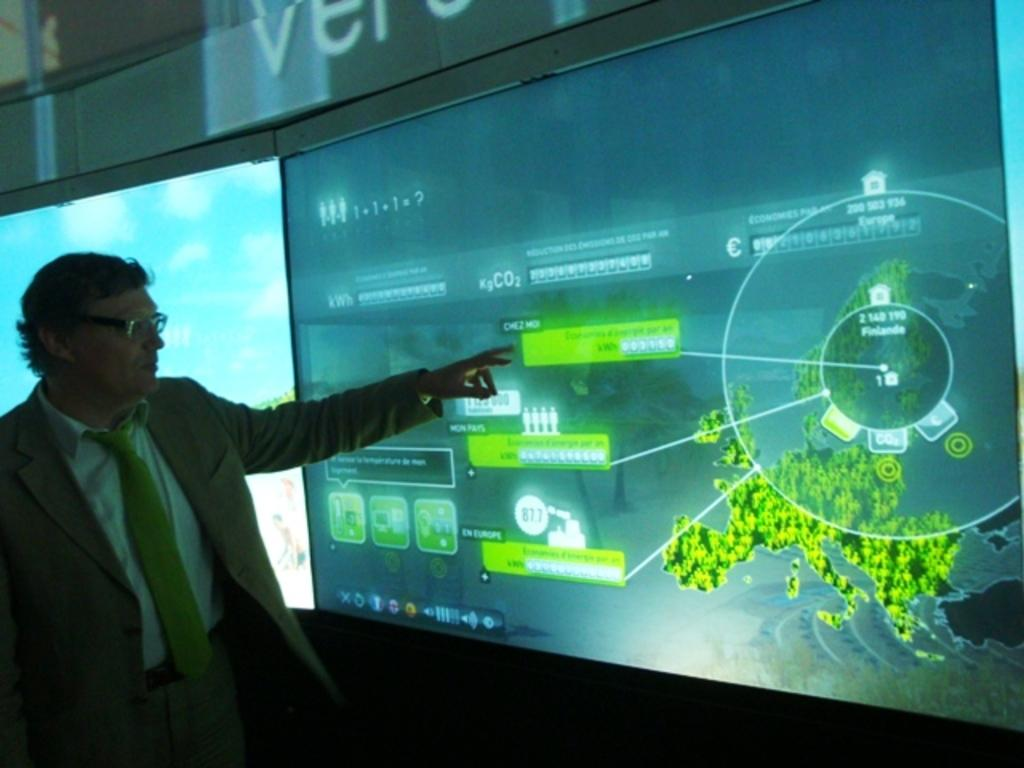<image>
Share a concise interpretation of the image provided. A lit screen is titled with a word that starts with a V. 